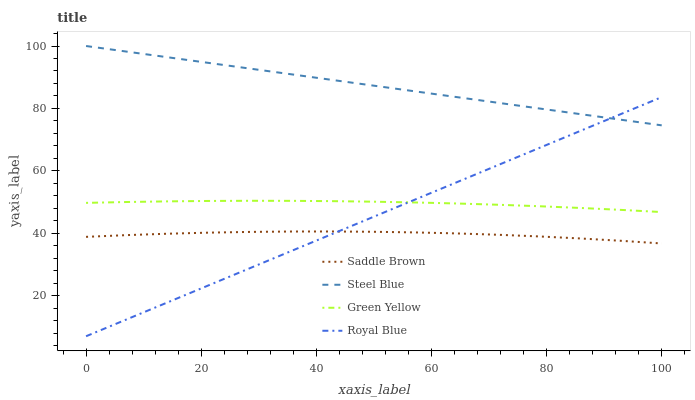Does Saddle Brown have the minimum area under the curve?
Answer yes or no. Yes. Does Steel Blue have the maximum area under the curve?
Answer yes or no. Yes. Does Green Yellow have the minimum area under the curve?
Answer yes or no. No. Does Green Yellow have the maximum area under the curve?
Answer yes or no. No. Is Royal Blue the smoothest?
Answer yes or no. Yes. Is Saddle Brown the roughest?
Answer yes or no. Yes. Is Green Yellow the smoothest?
Answer yes or no. No. Is Green Yellow the roughest?
Answer yes or no. No. Does Royal Blue have the lowest value?
Answer yes or no. Yes. Does Green Yellow have the lowest value?
Answer yes or no. No. Does Steel Blue have the highest value?
Answer yes or no. Yes. Does Green Yellow have the highest value?
Answer yes or no. No. Is Green Yellow less than Steel Blue?
Answer yes or no. Yes. Is Steel Blue greater than Green Yellow?
Answer yes or no. Yes. Does Royal Blue intersect Saddle Brown?
Answer yes or no. Yes. Is Royal Blue less than Saddle Brown?
Answer yes or no. No. Is Royal Blue greater than Saddle Brown?
Answer yes or no. No. Does Green Yellow intersect Steel Blue?
Answer yes or no. No. 